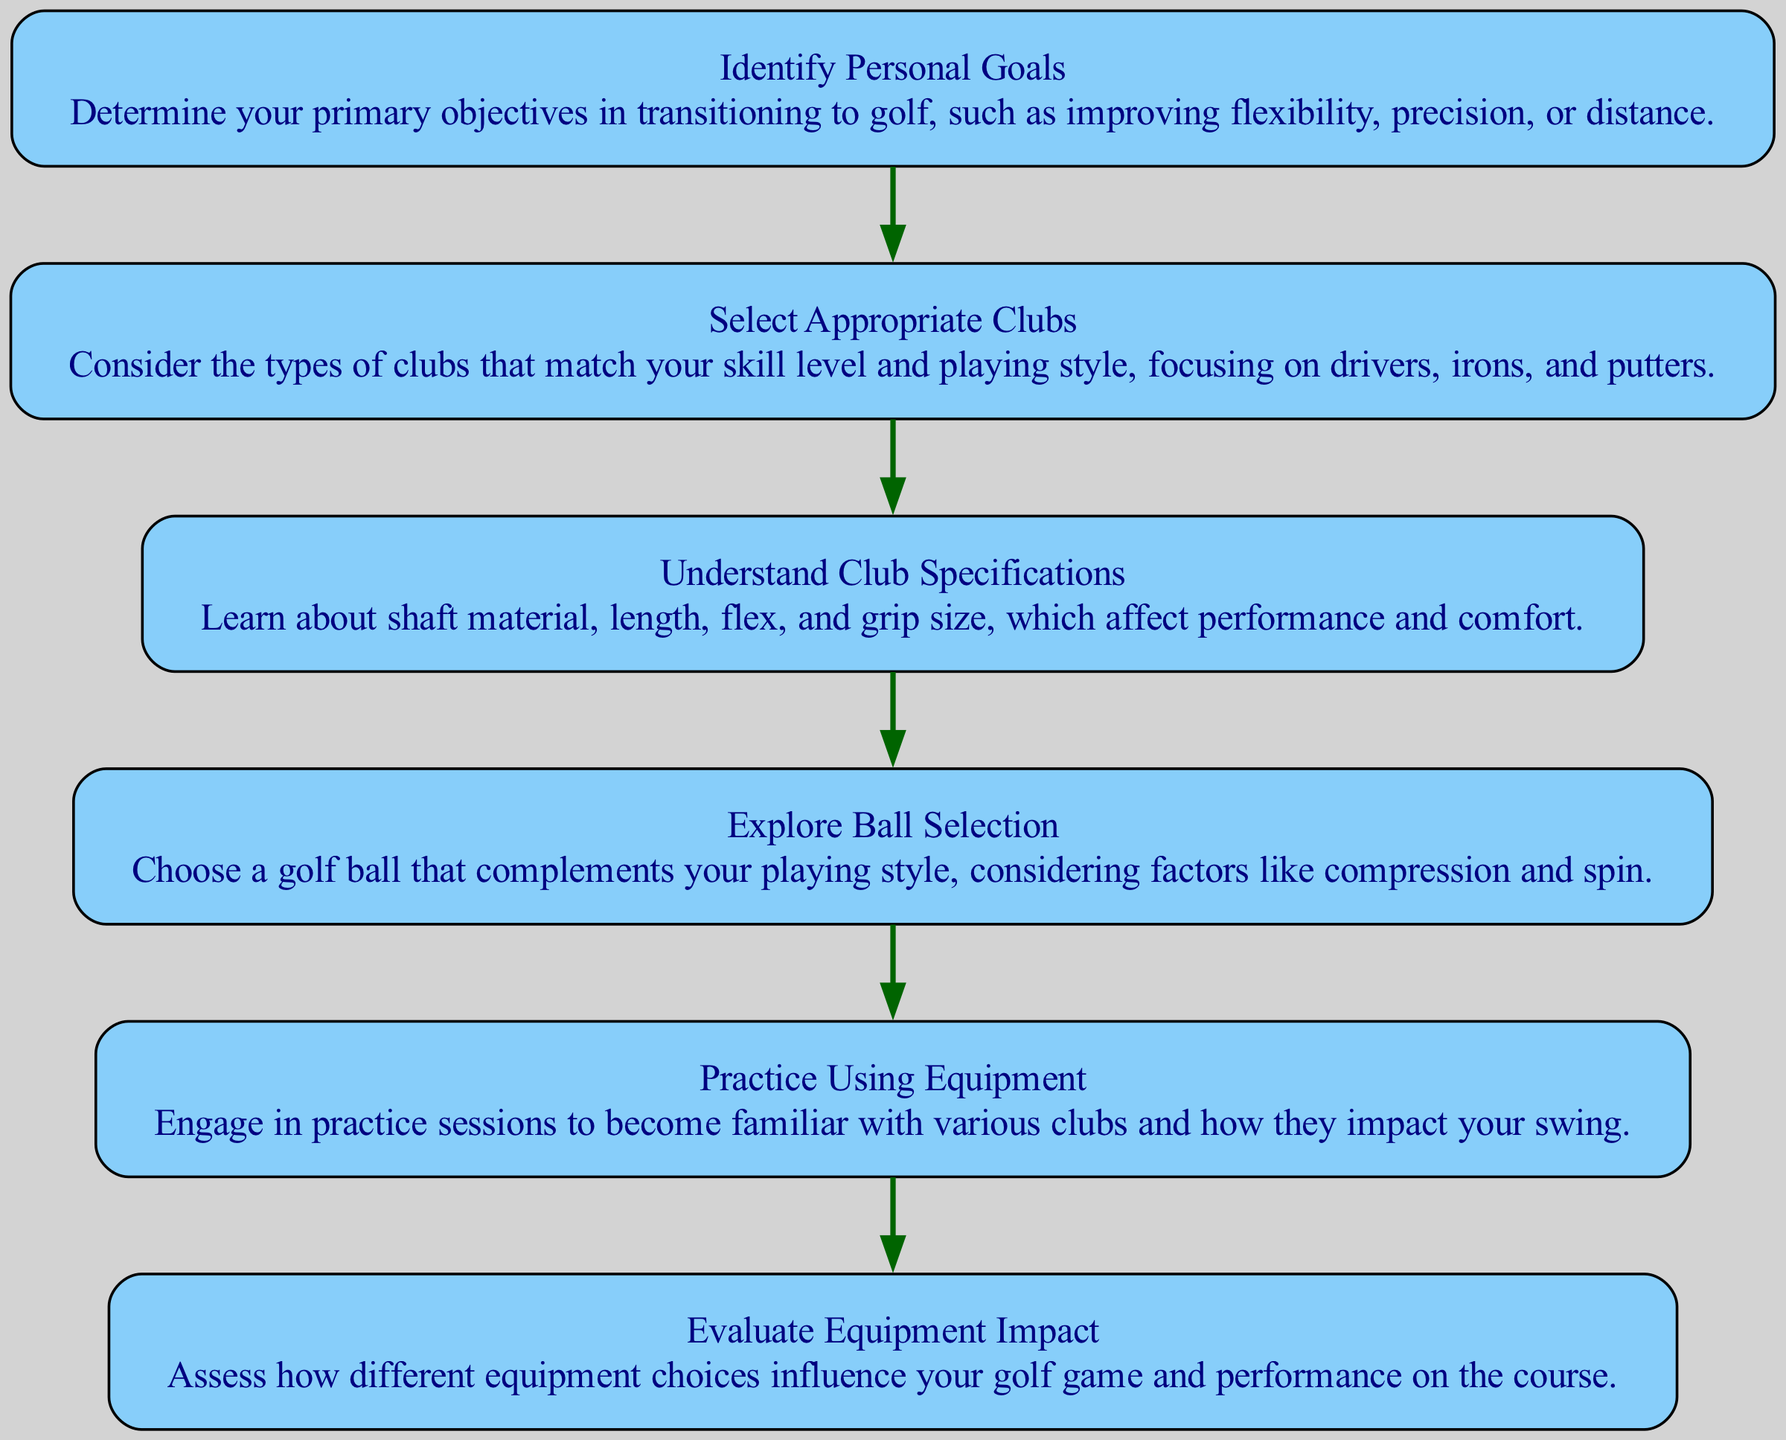What is the first step in the flow chart? The first step is "Identify Personal Goals", shown as the first node in the diagram.
Answer: Identify Personal Goals How many total elements are in the diagram? The diagram contains six elements, as counted from the list provided.
Answer: 6 What is the last step in the flow chart? The last step is "Evaluate Equipment Impact", which is the final node in the sequence.
Answer: Evaluate Equipment Impact Which element focuses on understanding club specifications? The element that deals with this topic is "Understand Club Specifications", specifically addressing the characteristics of the clubs.
Answer: Understand Club Specifications What type of equipment does the flow chart advise on before exploring ball selection? Before selecting a ball, the flow chart recommends "Select Appropriate Clubs", indicating a sequence in equipment selection.
Answer: Select Appropriate Clubs What is the relationship between "Select Appropriate Clubs" and "Practice Using Equipment"? "Select Appropriate Clubs" feeds into "Practice Using Equipment", indicating that you need to choose clubs before practicing with them.
Answer: Select Appropriate Clubs → Practice Using Equipment Which step comes after "Understand Club Specifications"? The step that follows is "Explore Ball Selection", showing a sequential progression in understanding golf equipment.
Answer: Explore Ball Selection What is the connection between "Practice Using Equipment" and "Evaluate Equipment Impact"? "Practice Using Equipment" leads to "Evaluate Equipment Impact", suggesting that practice helps to assess the effectiveness of the equipment used.
Answer: Practice Using Equipment → Evaluate Equipment Impact Which node emphasizes the importance of personal goals in transitioning to golf? The node "Identify Personal Goals" emphasizes this importance, indicating that goals should be determined first before proceeding with the transition.
Answer: Identify Personal Goals 